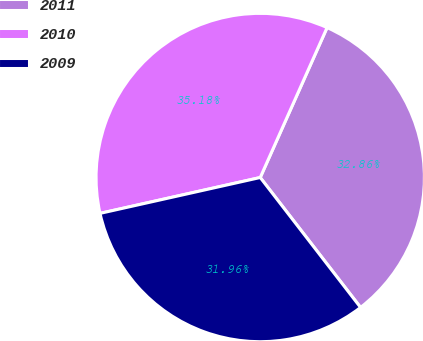Convert chart to OTSL. <chart><loc_0><loc_0><loc_500><loc_500><pie_chart><fcel>2011<fcel>2010<fcel>2009<nl><fcel>32.86%<fcel>35.18%<fcel>31.96%<nl></chart> 